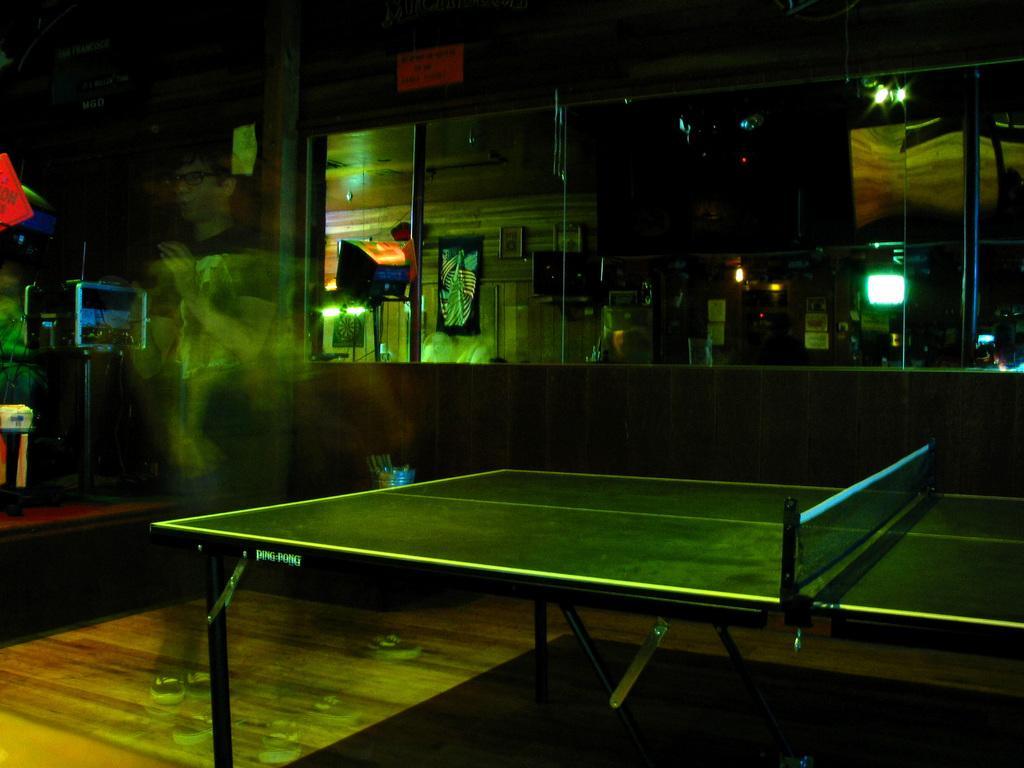In one or two sentences, can you explain what this image depicts? In the image I can see a table which has a net attached to it. In the background I can see framed glass wall, lights and some other objects on the floor. 